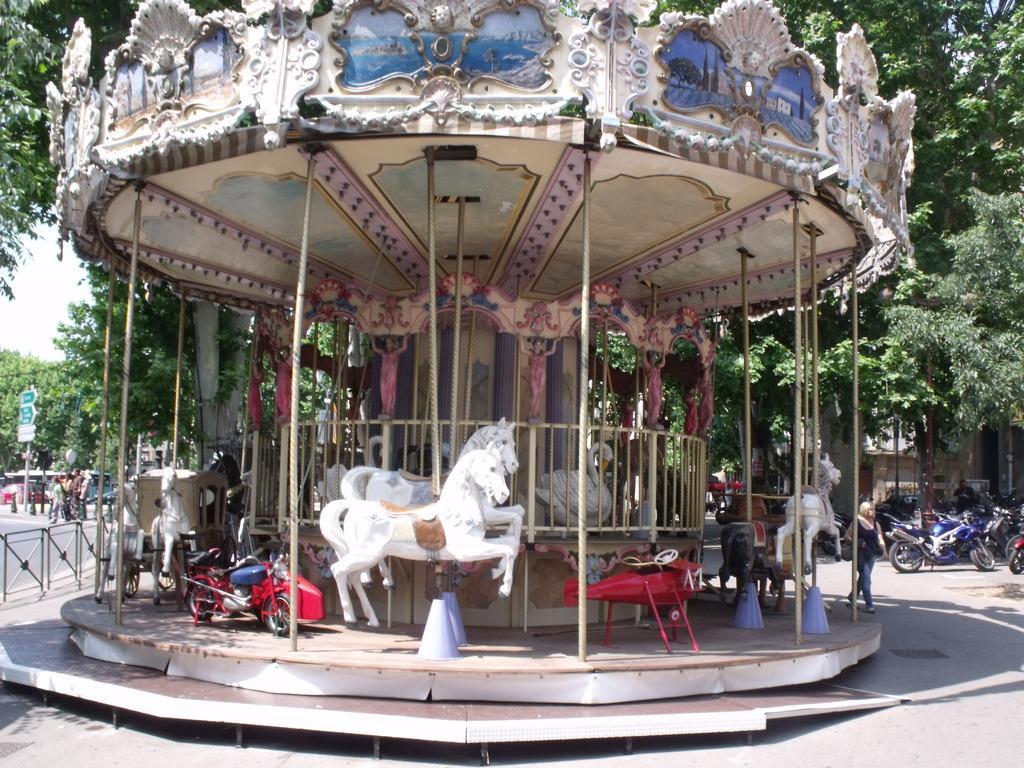How would you summarize this image in a sentence or two? In this picture I can observe carousel in the middle of the picture. On the right side I can observe bikes parked in the parking lot. In the background I can observe trees. 